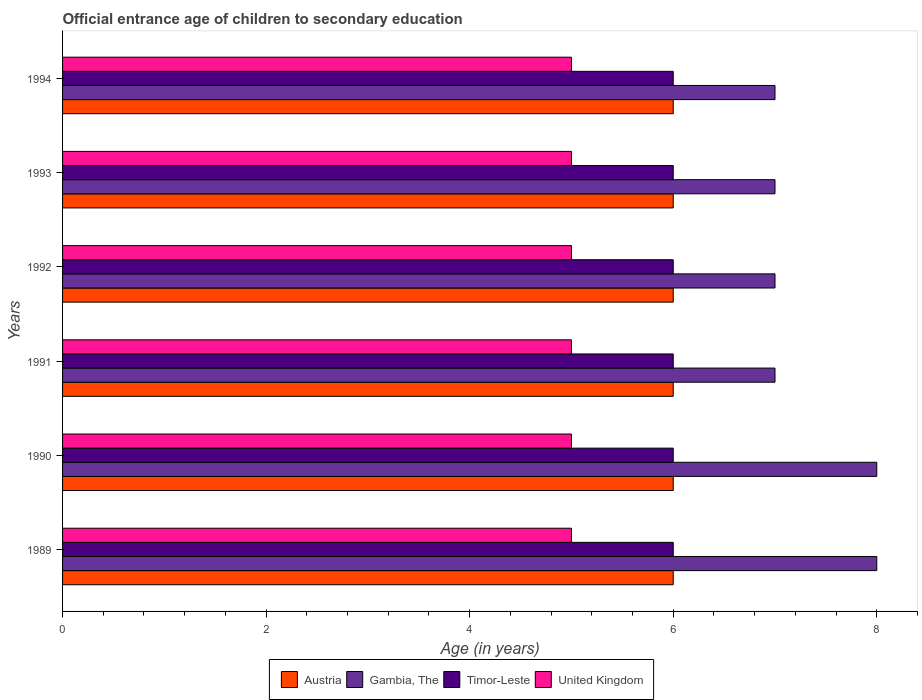How many groups of bars are there?
Provide a short and direct response. 6. Are the number of bars per tick equal to the number of legend labels?
Keep it short and to the point. Yes. Are the number of bars on each tick of the Y-axis equal?
Ensure brevity in your answer.  Yes. What is the label of the 1st group of bars from the top?
Keep it short and to the point. 1994. What is the secondary school starting age of children in Austria in 1993?
Your answer should be very brief. 6. Across all years, what is the maximum secondary school starting age of children in Gambia, The?
Your answer should be compact. 8. Across all years, what is the minimum secondary school starting age of children in United Kingdom?
Provide a succinct answer. 5. In which year was the secondary school starting age of children in Austria maximum?
Offer a very short reply. 1989. In which year was the secondary school starting age of children in Timor-Leste minimum?
Keep it short and to the point. 1989. What is the total secondary school starting age of children in United Kingdom in the graph?
Ensure brevity in your answer.  30. What is the difference between the secondary school starting age of children in Timor-Leste in 1993 and the secondary school starting age of children in United Kingdom in 1994?
Your answer should be compact. 1. What is the average secondary school starting age of children in Gambia, The per year?
Your answer should be compact. 7.33. In the year 1991, what is the difference between the secondary school starting age of children in Austria and secondary school starting age of children in United Kingdom?
Your response must be concise. 1. Is the secondary school starting age of children in Austria in 1990 less than that in 1994?
Your answer should be very brief. No. What is the difference between the highest and the second highest secondary school starting age of children in Timor-Leste?
Provide a succinct answer. 0. What is the difference between the highest and the lowest secondary school starting age of children in Gambia, The?
Provide a short and direct response. 1. Is the sum of the secondary school starting age of children in Timor-Leste in 1989 and 1993 greater than the maximum secondary school starting age of children in United Kingdom across all years?
Ensure brevity in your answer.  Yes. What does the 4th bar from the bottom in 1993 represents?
Offer a very short reply. United Kingdom. How many years are there in the graph?
Keep it short and to the point. 6. Does the graph contain any zero values?
Your answer should be compact. No. Does the graph contain grids?
Provide a succinct answer. No. Where does the legend appear in the graph?
Provide a succinct answer. Bottom center. How are the legend labels stacked?
Provide a succinct answer. Horizontal. What is the title of the graph?
Your answer should be very brief. Official entrance age of children to secondary education. What is the label or title of the X-axis?
Provide a succinct answer. Age (in years). What is the Age (in years) of Austria in 1989?
Provide a short and direct response. 6. What is the Age (in years) in Timor-Leste in 1990?
Offer a very short reply. 6. What is the Age (in years) of United Kingdom in 1990?
Make the answer very short. 5. What is the Age (in years) of Austria in 1991?
Ensure brevity in your answer.  6. What is the Age (in years) in Gambia, The in 1991?
Provide a succinct answer. 7. What is the Age (in years) of United Kingdom in 1991?
Offer a very short reply. 5. What is the Age (in years) of Austria in 1992?
Make the answer very short. 6. What is the Age (in years) of Austria in 1993?
Ensure brevity in your answer.  6. What is the Age (in years) in Austria in 1994?
Provide a short and direct response. 6. What is the Age (in years) in Timor-Leste in 1994?
Offer a terse response. 6. Across all years, what is the maximum Age (in years) in Gambia, The?
Offer a very short reply. 8. Across all years, what is the maximum Age (in years) of United Kingdom?
Provide a succinct answer. 5. Across all years, what is the minimum Age (in years) in Austria?
Make the answer very short. 6. What is the total Age (in years) in Austria in the graph?
Your answer should be compact. 36. What is the total Age (in years) of Gambia, The in the graph?
Ensure brevity in your answer.  44. What is the total Age (in years) of United Kingdom in the graph?
Offer a very short reply. 30. What is the difference between the Age (in years) of Timor-Leste in 1989 and that in 1990?
Your answer should be compact. 0. What is the difference between the Age (in years) in United Kingdom in 1989 and that in 1990?
Make the answer very short. 0. What is the difference between the Age (in years) of Austria in 1989 and that in 1991?
Keep it short and to the point. 0. What is the difference between the Age (in years) of Timor-Leste in 1989 and that in 1991?
Offer a terse response. 0. What is the difference between the Age (in years) of United Kingdom in 1989 and that in 1991?
Your response must be concise. 0. What is the difference between the Age (in years) of Austria in 1989 and that in 1992?
Make the answer very short. 0. What is the difference between the Age (in years) of United Kingdom in 1989 and that in 1992?
Ensure brevity in your answer.  0. What is the difference between the Age (in years) of Gambia, The in 1989 and that in 1993?
Provide a short and direct response. 1. What is the difference between the Age (in years) in United Kingdom in 1989 and that in 1993?
Offer a very short reply. 0. What is the difference between the Age (in years) in Timor-Leste in 1989 and that in 1994?
Give a very brief answer. 0. What is the difference between the Age (in years) in United Kingdom in 1989 and that in 1994?
Your answer should be very brief. 0. What is the difference between the Age (in years) in Austria in 1990 and that in 1991?
Your answer should be very brief. 0. What is the difference between the Age (in years) in Timor-Leste in 1990 and that in 1991?
Give a very brief answer. 0. What is the difference between the Age (in years) of United Kingdom in 1990 and that in 1991?
Your response must be concise. 0. What is the difference between the Age (in years) in Gambia, The in 1990 and that in 1992?
Offer a very short reply. 1. What is the difference between the Age (in years) of Timor-Leste in 1990 and that in 1992?
Make the answer very short. 0. What is the difference between the Age (in years) of Gambia, The in 1990 and that in 1993?
Provide a succinct answer. 1. What is the difference between the Age (in years) in Austria in 1990 and that in 1994?
Provide a short and direct response. 0. What is the difference between the Age (in years) in Gambia, The in 1990 and that in 1994?
Make the answer very short. 1. What is the difference between the Age (in years) of United Kingdom in 1990 and that in 1994?
Give a very brief answer. 0. What is the difference between the Age (in years) of United Kingdom in 1991 and that in 1992?
Your response must be concise. 0. What is the difference between the Age (in years) of Austria in 1991 and that in 1993?
Your answer should be compact. 0. What is the difference between the Age (in years) in United Kingdom in 1991 and that in 1993?
Offer a terse response. 0. What is the difference between the Age (in years) in Timor-Leste in 1991 and that in 1994?
Ensure brevity in your answer.  0. What is the difference between the Age (in years) in United Kingdom in 1991 and that in 1994?
Offer a terse response. 0. What is the difference between the Age (in years) in Austria in 1992 and that in 1994?
Make the answer very short. 0. What is the difference between the Age (in years) in Gambia, The in 1992 and that in 1994?
Your response must be concise. 0. What is the difference between the Age (in years) in United Kingdom in 1992 and that in 1994?
Offer a very short reply. 0. What is the difference between the Age (in years) of Austria in 1993 and that in 1994?
Provide a succinct answer. 0. What is the difference between the Age (in years) of Gambia, The in 1993 and that in 1994?
Keep it short and to the point. 0. What is the difference between the Age (in years) of Austria in 1989 and the Age (in years) of Gambia, The in 1990?
Offer a very short reply. -2. What is the difference between the Age (in years) of Austria in 1989 and the Age (in years) of Timor-Leste in 1990?
Your answer should be very brief. 0. What is the difference between the Age (in years) in Austria in 1989 and the Age (in years) in United Kingdom in 1990?
Provide a short and direct response. 1. What is the difference between the Age (in years) of Timor-Leste in 1989 and the Age (in years) of United Kingdom in 1990?
Ensure brevity in your answer.  1. What is the difference between the Age (in years) in Austria in 1989 and the Age (in years) in Timor-Leste in 1991?
Provide a short and direct response. 0. What is the difference between the Age (in years) of Austria in 1989 and the Age (in years) of United Kingdom in 1991?
Give a very brief answer. 1. What is the difference between the Age (in years) in Gambia, The in 1989 and the Age (in years) in United Kingdom in 1991?
Your answer should be very brief. 3. What is the difference between the Age (in years) in Timor-Leste in 1989 and the Age (in years) in United Kingdom in 1991?
Your response must be concise. 1. What is the difference between the Age (in years) in Gambia, The in 1989 and the Age (in years) in United Kingdom in 1992?
Ensure brevity in your answer.  3. What is the difference between the Age (in years) of Austria in 1989 and the Age (in years) of Timor-Leste in 1993?
Your response must be concise. 0. What is the difference between the Age (in years) of Gambia, The in 1989 and the Age (in years) of Timor-Leste in 1993?
Make the answer very short. 2. What is the difference between the Age (in years) in Timor-Leste in 1989 and the Age (in years) in United Kingdom in 1993?
Offer a very short reply. 1. What is the difference between the Age (in years) in Austria in 1989 and the Age (in years) in Timor-Leste in 1994?
Provide a short and direct response. 0. What is the difference between the Age (in years) in Gambia, The in 1989 and the Age (in years) in Timor-Leste in 1994?
Your response must be concise. 2. What is the difference between the Age (in years) in Gambia, The in 1989 and the Age (in years) in United Kingdom in 1994?
Offer a terse response. 3. What is the difference between the Age (in years) in Austria in 1990 and the Age (in years) in Timor-Leste in 1991?
Ensure brevity in your answer.  0. What is the difference between the Age (in years) in Austria in 1990 and the Age (in years) in United Kingdom in 1991?
Offer a very short reply. 1. What is the difference between the Age (in years) of Gambia, The in 1990 and the Age (in years) of Timor-Leste in 1991?
Ensure brevity in your answer.  2. What is the difference between the Age (in years) of Gambia, The in 1990 and the Age (in years) of United Kingdom in 1991?
Make the answer very short. 3. What is the difference between the Age (in years) of Timor-Leste in 1990 and the Age (in years) of United Kingdom in 1991?
Keep it short and to the point. 1. What is the difference between the Age (in years) in Gambia, The in 1990 and the Age (in years) in United Kingdom in 1992?
Provide a short and direct response. 3. What is the difference between the Age (in years) in Austria in 1990 and the Age (in years) in Gambia, The in 1993?
Give a very brief answer. -1. What is the difference between the Age (in years) of Austria in 1990 and the Age (in years) of United Kingdom in 1993?
Give a very brief answer. 1. What is the difference between the Age (in years) in Gambia, The in 1990 and the Age (in years) in Timor-Leste in 1993?
Offer a very short reply. 2. What is the difference between the Age (in years) in Timor-Leste in 1990 and the Age (in years) in United Kingdom in 1993?
Your answer should be very brief. 1. What is the difference between the Age (in years) of Austria in 1990 and the Age (in years) of Gambia, The in 1994?
Make the answer very short. -1. What is the difference between the Age (in years) of Austria in 1990 and the Age (in years) of Timor-Leste in 1994?
Offer a very short reply. 0. What is the difference between the Age (in years) of Gambia, The in 1990 and the Age (in years) of Timor-Leste in 1994?
Your answer should be compact. 2. What is the difference between the Age (in years) in Gambia, The in 1990 and the Age (in years) in United Kingdom in 1994?
Provide a succinct answer. 3. What is the difference between the Age (in years) in Austria in 1991 and the Age (in years) in Timor-Leste in 1992?
Give a very brief answer. 0. What is the difference between the Age (in years) in Gambia, The in 1991 and the Age (in years) in United Kingdom in 1992?
Ensure brevity in your answer.  2. What is the difference between the Age (in years) of Timor-Leste in 1991 and the Age (in years) of United Kingdom in 1992?
Your response must be concise. 1. What is the difference between the Age (in years) in Austria in 1991 and the Age (in years) in United Kingdom in 1993?
Your answer should be compact. 1. What is the difference between the Age (in years) in Gambia, The in 1991 and the Age (in years) in Timor-Leste in 1993?
Keep it short and to the point. 1. What is the difference between the Age (in years) of Timor-Leste in 1991 and the Age (in years) of United Kingdom in 1993?
Make the answer very short. 1. What is the difference between the Age (in years) of Austria in 1991 and the Age (in years) of Gambia, The in 1994?
Ensure brevity in your answer.  -1. What is the difference between the Age (in years) of Austria in 1991 and the Age (in years) of Timor-Leste in 1994?
Your answer should be compact. 0. What is the difference between the Age (in years) in Gambia, The in 1991 and the Age (in years) in Timor-Leste in 1994?
Make the answer very short. 1. What is the difference between the Age (in years) in Gambia, The in 1991 and the Age (in years) in United Kingdom in 1994?
Your answer should be very brief. 2. What is the difference between the Age (in years) of Timor-Leste in 1991 and the Age (in years) of United Kingdom in 1994?
Your answer should be very brief. 1. What is the difference between the Age (in years) in Austria in 1992 and the Age (in years) in Gambia, The in 1993?
Your answer should be very brief. -1. What is the difference between the Age (in years) in Austria in 1992 and the Age (in years) in United Kingdom in 1993?
Offer a terse response. 1. What is the difference between the Age (in years) in Gambia, The in 1992 and the Age (in years) in Timor-Leste in 1993?
Provide a succinct answer. 1. What is the difference between the Age (in years) in Austria in 1992 and the Age (in years) in Gambia, The in 1994?
Keep it short and to the point. -1. What is the difference between the Age (in years) in Austria in 1992 and the Age (in years) in United Kingdom in 1994?
Give a very brief answer. 1. What is the difference between the Age (in years) in Gambia, The in 1992 and the Age (in years) in Timor-Leste in 1994?
Keep it short and to the point. 1. What is the difference between the Age (in years) of Austria in 1993 and the Age (in years) of Timor-Leste in 1994?
Your answer should be very brief. 0. What is the difference between the Age (in years) in Austria in 1993 and the Age (in years) in United Kingdom in 1994?
Give a very brief answer. 1. What is the average Age (in years) in Gambia, The per year?
Keep it short and to the point. 7.33. What is the average Age (in years) in Timor-Leste per year?
Your answer should be very brief. 6. What is the average Age (in years) of United Kingdom per year?
Provide a short and direct response. 5. In the year 1989, what is the difference between the Age (in years) of Austria and Age (in years) of Gambia, The?
Offer a very short reply. -2. In the year 1989, what is the difference between the Age (in years) in Gambia, The and Age (in years) in Timor-Leste?
Ensure brevity in your answer.  2. In the year 1990, what is the difference between the Age (in years) of Austria and Age (in years) of Timor-Leste?
Offer a very short reply. 0. In the year 1991, what is the difference between the Age (in years) in Austria and Age (in years) in Timor-Leste?
Ensure brevity in your answer.  0. In the year 1991, what is the difference between the Age (in years) of Austria and Age (in years) of United Kingdom?
Ensure brevity in your answer.  1. In the year 1991, what is the difference between the Age (in years) in Gambia, The and Age (in years) in Timor-Leste?
Your answer should be very brief. 1. In the year 1992, what is the difference between the Age (in years) of Austria and Age (in years) of United Kingdom?
Ensure brevity in your answer.  1. In the year 1993, what is the difference between the Age (in years) of Austria and Age (in years) of Gambia, The?
Make the answer very short. -1. In the year 1993, what is the difference between the Age (in years) of Austria and Age (in years) of United Kingdom?
Give a very brief answer. 1. In the year 1993, what is the difference between the Age (in years) of Gambia, The and Age (in years) of Timor-Leste?
Provide a short and direct response. 1. In the year 1994, what is the difference between the Age (in years) of Austria and Age (in years) of Gambia, The?
Your answer should be very brief. -1. In the year 1994, what is the difference between the Age (in years) of Gambia, The and Age (in years) of Timor-Leste?
Provide a short and direct response. 1. In the year 1994, what is the difference between the Age (in years) of Gambia, The and Age (in years) of United Kingdom?
Make the answer very short. 2. In the year 1994, what is the difference between the Age (in years) in Timor-Leste and Age (in years) in United Kingdom?
Offer a terse response. 1. What is the ratio of the Age (in years) in United Kingdom in 1989 to that in 1990?
Offer a very short reply. 1. What is the ratio of the Age (in years) of Austria in 1989 to that in 1991?
Provide a succinct answer. 1. What is the ratio of the Age (in years) of United Kingdom in 1989 to that in 1991?
Offer a very short reply. 1. What is the ratio of the Age (in years) in Austria in 1989 to that in 1992?
Give a very brief answer. 1. What is the ratio of the Age (in years) in Gambia, The in 1989 to that in 1992?
Your answer should be compact. 1.14. What is the ratio of the Age (in years) of Gambia, The in 1989 to that in 1993?
Provide a short and direct response. 1.14. What is the ratio of the Age (in years) in Timor-Leste in 1989 to that in 1994?
Your answer should be very brief. 1. What is the ratio of the Age (in years) of United Kingdom in 1989 to that in 1994?
Offer a very short reply. 1. What is the ratio of the Age (in years) of Austria in 1990 to that in 1991?
Ensure brevity in your answer.  1. What is the ratio of the Age (in years) of Gambia, The in 1990 to that in 1991?
Your answer should be compact. 1.14. What is the ratio of the Age (in years) of Austria in 1990 to that in 1992?
Offer a terse response. 1. What is the ratio of the Age (in years) in United Kingdom in 1990 to that in 1992?
Make the answer very short. 1. What is the ratio of the Age (in years) in Gambia, The in 1990 to that in 1993?
Offer a very short reply. 1.14. What is the ratio of the Age (in years) of Timor-Leste in 1990 to that in 1993?
Your response must be concise. 1. What is the ratio of the Age (in years) in United Kingdom in 1990 to that in 1993?
Provide a succinct answer. 1. What is the ratio of the Age (in years) in Gambia, The in 1990 to that in 1994?
Ensure brevity in your answer.  1.14. What is the ratio of the Age (in years) in Timor-Leste in 1990 to that in 1994?
Your answer should be compact. 1. What is the ratio of the Age (in years) in Austria in 1991 to that in 1992?
Ensure brevity in your answer.  1. What is the ratio of the Age (in years) in Gambia, The in 1991 to that in 1992?
Offer a very short reply. 1. What is the ratio of the Age (in years) of Timor-Leste in 1991 to that in 1992?
Offer a terse response. 1. What is the ratio of the Age (in years) of United Kingdom in 1991 to that in 1992?
Your answer should be very brief. 1. What is the ratio of the Age (in years) in Gambia, The in 1991 to that in 1993?
Your answer should be very brief. 1. What is the ratio of the Age (in years) in Gambia, The in 1991 to that in 1994?
Keep it short and to the point. 1. What is the ratio of the Age (in years) in Timor-Leste in 1991 to that in 1994?
Your response must be concise. 1. What is the ratio of the Age (in years) in United Kingdom in 1991 to that in 1994?
Give a very brief answer. 1. What is the ratio of the Age (in years) of Timor-Leste in 1992 to that in 1993?
Your response must be concise. 1. What is the ratio of the Age (in years) of United Kingdom in 1992 to that in 1993?
Offer a terse response. 1. What is the ratio of the Age (in years) of Austria in 1992 to that in 1994?
Make the answer very short. 1. What is the ratio of the Age (in years) of United Kingdom in 1992 to that in 1994?
Ensure brevity in your answer.  1. What is the ratio of the Age (in years) in Gambia, The in 1993 to that in 1994?
Give a very brief answer. 1. What is the ratio of the Age (in years) of United Kingdom in 1993 to that in 1994?
Your answer should be very brief. 1. What is the difference between the highest and the second highest Age (in years) in Austria?
Your answer should be very brief. 0. What is the difference between the highest and the lowest Age (in years) of Austria?
Provide a succinct answer. 0. What is the difference between the highest and the lowest Age (in years) of United Kingdom?
Provide a short and direct response. 0. 